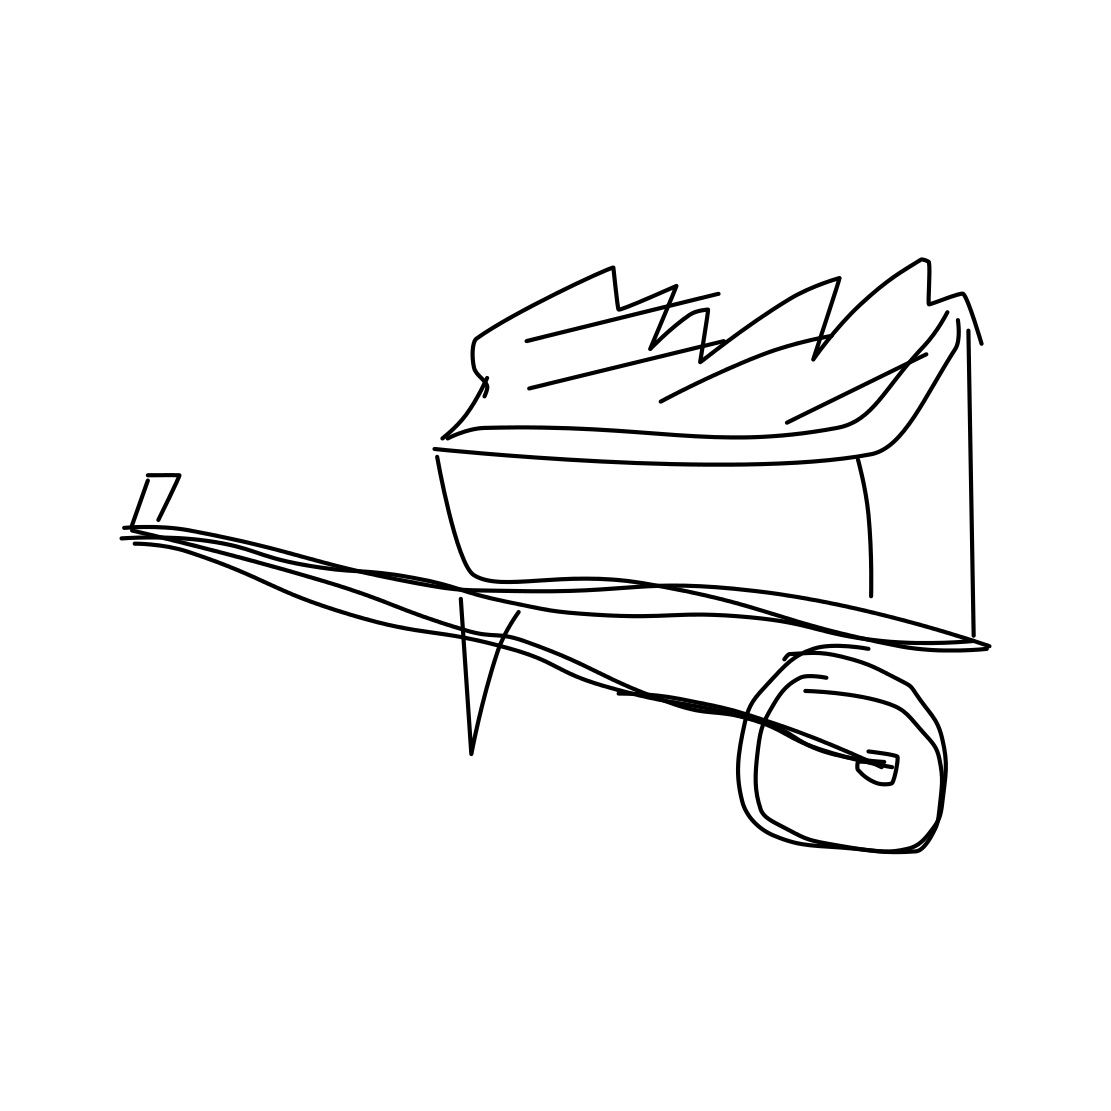In the scene, is a snowboard in it? No 